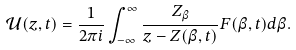Convert formula to latex. <formula><loc_0><loc_0><loc_500><loc_500>\mathcal { U } ( z , t ) = \frac { 1 } { 2 \pi i } \int _ { - \infty } ^ { \infty } \frac { Z _ { \beta } } { z - Z ( \beta , t ) } F ( \beta , t ) d \beta .</formula> 